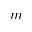<formula> <loc_0><loc_0><loc_500><loc_500>m</formula> 